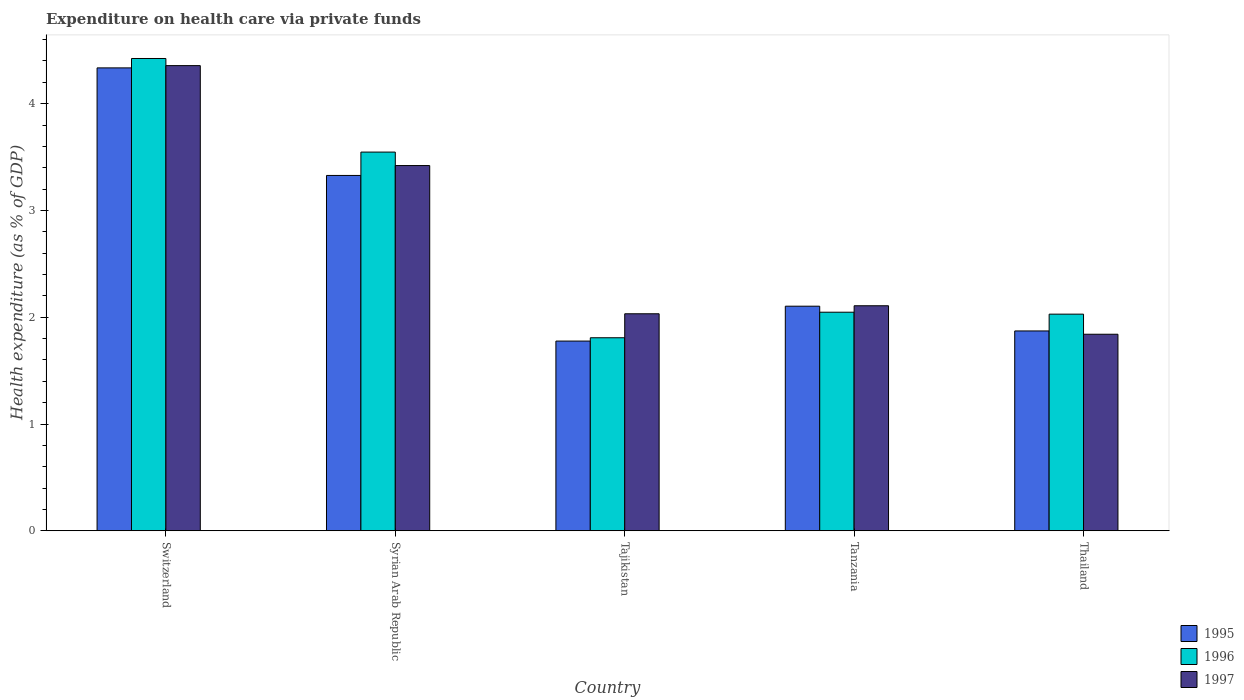How many different coloured bars are there?
Give a very brief answer. 3. How many groups of bars are there?
Your response must be concise. 5. Are the number of bars on each tick of the X-axis equal?
Your answer should be very brief. Yes. How many bars are there on the 1st tick from the left?
Make the answer very short. 3. How many bars are there on the 5th tick from the right?
Your answer should be compact. 3. What is the label of the 3rd group of bars from the left?
Provide a succinct answer. Tajikistan. What is the expenditure made on health care in 1996 in Syrian Arab Republic?
Your answer should be very brief. 3.55. Across all countries, what is the maximum expenditure made on health care in 1996?
Your answer should be compact. 4.42. Across all countries, what is the minimum expenditure made on health care in 1995?
Provide a short and direct response. 1.78. In which country was the expenditure made on health care in 1996 maximum?
Keep it short and to the point. Switzerland. In which country was the expenditure made on health care in 1997 minimum?
Your response must be concise. Thailand. What is the total expenditure made on health care in 1996 in the graph?
Your response must be concise. 13.85. What is the difference between the expenditure made on health care in 1995 in Tajikistan and that in Thailand?
Ensure brevity in your answer.  -0.09. What is the difference between the expenditure made on health care in 1997 in Syrian Arab Republic and the expenditure made on health care in 1996 in Tanzania?
Your answer should be very brief. 1.37. What is the average expenditure made on health care in 1996 per country?
Your answer should be compact. 2.77. What is the difference between the expenditure made on health care of/in 1996 and expenditure made on health care of/in 1997 in Tanzania?
Keep it short and to the point. -0.06. In how many countries, is the expenditure made on health care in 1997 greater than 0.4 %?
Your answer should be compact. 5. What is the ratio of the expenditure made on health care in 1997 in Syrian Arab Republic to that in Tanzania?
Provide a succinct answer. 1.62. Is the difference between the expenditure made on health care in 1996 in Tanzania and Thailand greater than the difference between the expenditure made on health care in 1997 in Tanzania and Thailand?
Offer a very short reply. No. What is the difference between the highest and the second highest expenditure made on health care in 1996?
Give a very brief answer. -1.5. What is the difference between the highest and the lowest expenditure made on health care in 1995?
Provide a short and direct response. 2.56. In how many countries, is the expenditure made on health care in 1997 greater than the average expenditure made on health care in 1997 taken over all countries?
Make the answer very short. 2. What does the 2nd bar from the left in Tajikistan represents?
Ensure brevity in your answer.  1996. Is it the case that in every country, the sum of the expenditure made on health care in 1995 and expenditure made on health care in 1996 is greater than the expenditure made on health care in 1997?
Offer a very short reply. Yes. How many bars are there?
Provide a short and direct response. 15. Are the values on the major ticks of Y-axis written in scientific E-notation?
Give a very brief answer. No. Does the graph contain any zero values?
Provide a short and direct response. No. Does the graph contain grids?
Offer a very short reply. No. Where does the legend appear in the graph?
Your answer should be very brief. Bottom right. How many legend labels are there?
Keep it short and to the point. 3. How are the legend labels stacked?
Make the answer very short. Vertical. What is the title of the graph?
Your response must be concise. Expenditure on health care via private funds. What is the label or title of the Y-axis?
Provide a succinct answer. Health expenditure (as % of GDP). What is the Health expenditure (as % of GDP) of 1995 in Switzerland?
Offer a very short reply. 4.33. What is the Health expenditure (as % of GDP) in 1996 in Switzerland?
Your answer should be very brief. 4.42. What is the Health expenditure (as % of GDP) of 1997 in Switzerland?
Your answer should be compact. 4.36. What is the Health expenditure (as % of GDP) of 1995 in Syrian Arab Republic?
Give a very brief answer. 3.33. What is the Health expenditure (as % of GDP) in 1996 in Syrian Arab Republic?
Keep it short and to the point. 3.55. What is the Health expenditure (as % of GDP) of 1997 in Syrian Arab Republic?
Your answer should be compact. 3.42. What is the Health expenditure (as % of GDP) in 1995 in Tajikistan?
Provide a succinct answer. 1.78. What is the Health expenditure (as % of GDP) in 1996 in Tajikistan?
Offer a terse response. 1.81. What is the Health expenditure (as % of GDP) of 1997 in Tajikistan?
Keep it short and to the point. 2.03. What is the Health expenditure (as % of GDP) in 1995 in Tanzania?
Give a very brief answer. 2.1. What is the Health expenditure (as % of GDP) of 1996 in Tanzania?
Provide a succinct answer. 2.05. What is the Health expenditure (as % of GDP) of 1997 in Tanzania?
Provide a succinct answer. 2.11. What is the Health expenditure (as % of GDP) of 1995 in Thailand?
Provide a short and direct response. 1.87. What is the Health expenditure (as % of GDP) of 1996 in Thailand?
Your response must be concise. 2.03. What is the Health expenditure (as % of GDP) in 1997 in Thailand?
Your response must be concise. 1.84. Across all countries, what is the maximum Health expenditure (as % of GDP) in 1995?
Provide a succinct answer. 4.33. Across all countries, what is the maximum Health expenditure (as % of GDP) of 1996?
Give a very brief answer. 4.42. Across all countries, what is the maximum Health expenditure (as % of GDP) of 1997?
Your response must be concise. 4.36. Across all countries, what is the minimum Health expenditure (as % of GDP) of 1995?
Offer a very short reply. 1.78. Across all countries, what is the minimum Health expenditure (as % of GDP) in 1996?
Provide a short and direct response. 1.81. Across all countries, what is the minimum Health expenditure (as % of GDP) of 1997?
Provide a short and direct response. 1.84. What is the total Health expenditure (as % of GDP) of 1995 in the graph?
Provide a succinct answer. 13.41. What is the total Health expenditure (as % of GDP) of 1996 in the graph?
Keep it short and to the point. 13.85. What is the total Health expenditure (as % of GDP) in 1997 in the graph?
Provide a succinct answer. 13.76. What is the difference between the Health expenditure (as % of GDP) of 1996 in Switzerland and that in Syrian Arab Republic?
Your answer should be compact. 0.88. What is the difference between the Health expenditure (as % of GDP) in 1997 in Switzerland and that in Syrian Arab Republic?
Ensure brevity in your answer.  0.94. What is the difference between the Health expenditure (as % of GDP) of 1995 in Switzerland and that in Tajikistan?
Your answer should be compact. 2.56. What is the difference between the Health expenditure (as % of GDP) in 1996 in Switzerland and that in Tajikistan?
Your response must be concise. 2.62. What is the difference between the Health expenditure (as % of GDP) of 1997 in Switzerland and that in Tajikistan?
Keep it short and to the point. 2.32. What is the difference between the Health expenditure (as % of GDP) of 1995 in Switzerland and that in Tanzania?
Keep it short and to the point. 2.23. What is the difference between the Health expenditure (as % of GDP) of 1996 in Switzerland and that in Tanzania?
Offer a very short reply. 2.38. What is the difference between the Health expenditure (as % of GDP) in 1997 in Switzerland and that in Tanzania?
Your answer should be very brief. 2.25. What is the difference between the Health expenditure (as % of GDP) in 1995 in Switzerland and that in Thailand?
Keep it short and to the point. 2.46. What is the difference between the Health expenditure (as % of GDP) of 1996 in Switzerland and that in Thailand?
Offer a very short reply. 2.39. What is the difference between the Health expenditure (as % of GDP) in 1997 in Switzerland and that in Thailand?
Your answer should be very brief. 2.52. What is the difference between the Health expenditure (as % of GDP) of 1995 in Syrian Arab Republic and that in Tajikistan?
Offer a very short reply. 1.55. What is the difference between the Health expenditure (as % of GDP) in 1996 in Syrian Arab Republic and that in Tajikistan?
Ensure brevity in your answer.  1.74. What is the difference between the Health expenditure (as % of GDP) in 1997 in Syrian Arab Republic and that in Tajikistan?
Make the answer very short. 1.39. What is the difference between the Health expenditure (as % of GDP) of 1995 in Syrian Arab Republic and that in Tanzania?
Provide a short and direct response. 1.22. What is the difference between the Health expenditure (as % of GDP) in 1996 in Syrian Arab Republic and that in Tanzania?
Your answer should be very brief. 1.5. What is the difference between the Health expenditure (as % of GDP) of 1997 in Syrian Arab Republic and that in Tanzania?
Ensure brevity in your answer.  1.31. What is the difference between the Health expenditure (as % of GDP) of 1995 in Syrian Arab Republic and that in Thailand?
Your answer should be very brief. 1.46. What is the difference between the Health expenditure (as % of GDP) of 1996 in Syrian Arab Republic and that in Thailand?
Offer a very short reply. 1.52. What is the difference between the Health expenditure (as % of GDP) of 1997 in Syrian Arab Republic and that in Thailand?
Provide a succinct answer. 1.58. What is the difference between the Health expenditure (as % of GDP) in 1995 in Tajikistan and that in Tanzania?
Your response must be concise. -0.33. What is the difference between the Health expenditure (as % of GDP) of 1996 in Tajikistan and that in Tanzania?
Keep it short and to the point. -0.24. What is the difference between the Health expenditure (as % of GDP) in 1997 in Tajikistan and that in Tanzania?
Offer a very short reply. -0.08. What is the difference between the Health expenditure (as % of GDP) in 1995 in Tajikistan and that in Thailand?
Your answer should be very brief. -0.09. What is the difference between the Health expenditure (as % of GDP) of 1996 in Tajikistan and that in Thailand?
Your answer should be compact. -0.22. What is the difference between the Health expenditure (as % of GDP) in 1997 in Tajikistan and that in Thailand?
Your response must be concise. 0.19. What is the difference between the Health expenditure (as % of GDP) of 1995 in Tanzania and that in Thailand?
Keep it short and to the point. 0.23. What is the difference between the Health expenditure (as % of GDP) in 1996 in Tanzania and that in Thailand?
Your response must be concise. 0.02. What is the difference between the Health expenditure (as % of GDP) of 1997 in Tanzania and that in Thailand?
Your response must be concise. 0.27. What is the difference between the Health expenditure (as % of GDP) of 1995 in Switzerland and the Health expenditure (as % of GDP) of 1996 in Syrian Arab Republic?
Your response must be concise. 0.79. What is the difference between the Health expenditure (as % of GDP) of 1995 in Switzerland and the Health expenditure (as % of GDP) of 1997 in Syrian Arab Republic?
Offer a terse response. 0.91. What is the difference between the Health expenditure (as % of GDP) of 1995 in Switzerland and the Health expenditure (as % of GDP) of 1996 in Tajikistan?
Your response must be concise. 2.53. What is the difference between the Health expenditure (as % of GDP) in 1995 in Switzerland and the Health expenditure (as % of GDP) in 1997 in Tajikistan?
Offer a terse response. 2.3. What is the difference between the Health expenditure (as % of GDP) of 1996 in Switzerland and the Health expenditure (as % of GDP) of 1997 in Tajikistan?
Ensure brevity in your answer.  2.39. What is the difference between the Health expenditure (as % of GDP) in 1995 in Switzerland and the Health expenditure (as % of GDP) in 1996 in Tanzania?
Provide a succinct answer. 2.29. What is the difference between the Health expenditure (as % of GDP) in 1995 in Switzerland and the Health expenditure (as % of GDP) in 1997 in Tanzania?
Provide a succinct answer. 2.23. What is the difference between the Health expenditure (as % of GDP) in 1996 in Switzerland and the Health expenditure (as % of GDP) in 1997 in Tanzania?
Offer a terse response. 2.32. What is the difference between the Health expenditure (as % of GDP) of 1995 in Switzerland and the Health expenditure (as % of GDP) of 1996 in Thailand?
Keep it short and to the point. 2.31. What is the difference between the Health expenditure (as % of GDP) in 1995 in Switzerland and the Health expenditure (as % of GDP) in 1997 in Thailand?
Your answer should be very brief. 2.49. What is the difference between the Health expenditure (as % of GDP) of 1996 in Switzerland and the Health expenditure (as % of GDP) of 1997 in Thailand?
Offer a terse response. 2.58. What is the difference between the Health expenditure (as % of GDP) of 1995 in Syrian Arab Republic and the Health expenditure (as % of GDP) of 1996 in Tajikistan?
Your response must be concise. 1.52. What is the difference between the Health expenditure (as % of GDP) of 1995 in Syrian Arab Republic and the Health expenditure (as % of GDP) of 1997 in Tajikistan?
Offer a very short reply. 1.3. What is the difference between the Health expenditure (as % of GDP) in 1996 in Syrian Arab Republic and the Health expenditure (as % of GDP) in 1997 in Tajikistan?
Give a very brief answer. 1.51. What is the difference between the Health expenditure (as % of GDP) in 1995 in Syrian Arab Republic and the Health expenditure (as % of GDP) in 1996 in Tanzania?
Provide a short and direct response. 1.28. What is the difference between the Health expenditure (as % of GDP) of 1995 in Syrian Arab Republic and the Health expenditure (as % of GDP) of 1997 in Tanzania?
Provide a short and direct response. 1.22. What is the difference between the Health expenditure (as % of GDP) of 1996 in Syrian Arab Republic and the Health expenditure (as % of GDP) of 1997 in Tanzania?
Your answer should be very brief. 1.44. What is the difference between the Health expenditure (as % of GDP) in 1995 in Syrian Arab Republic and the Health expenditure (as % of GDP) in 1996 in Thailand?
Provide a short and direct response. 1.3. What is the difference between the Health expenditure (as % of GDP) of 1995 in Syrian Arab Republic and the Health expenditure (as % of GDP) of 1997 in Thailand?
Offer a terse response. 1.49. What is the difference between the Health expenditure (as % of GDP) in 1996 in Syrian Arab Republic and the Health expenditure (as % of GDP) in 1997 in Thailand?
Make the answer very short. 1.71. What is the difference between the Health expenditure (as % of GDP) in 1995 in Tajikistan and the Health expenditure (as % of GDP) in 1996 in Tanzania?
Provide a succinct answer. -0.27. What is the difference between the Health expenditure (as % of GDP) of 1995 in Tajikistan and the Health expenditure (as % of GDP) of 1997 in Tanzania?
Ensure brevity in your answer.  -0.33. What is the difference between the Health expenditure (as % of GDP) in 1996 in Tajikistan and the Health expenditure (as % of GDP) in 1997 in Tanzania?
Your answer should be very brief. -0.3. What is the difference between the Health expenditure (as % of GDP) of 1995 in Tajikistan and the Health expenditure (as % of GDP) of 1996 in Thailand?
Provide a succinct answer. -0.25. What is the difference between the Health expenditure (as % of GDP) of 1995 in Tajikistan and the Health expenditure (as % of GDP) of 1997 in Thailand?
Ensure brevity in your answer.  -0.06. What is the difference between the Health expenditure (as % of GDP) of 1996 in Tajikistan and the Health expenditure (as % of GDP) of 1997 in Thailand?
Your answer should be compact. -0.03. What is the difference between the Health expenditure (as % of GDP) of 1995 in Tanzania and the Health expenditure (as % of GDP) of 1996 in Thailand?
Offer a very short reply. 0.07. What is the difference between the Health expenditure (as % of GDP) in 1995 in Tanzania and the Health expenditure (as % of GDP) in 1997 in Thailand?
Your answer should be compact. 0.26. What is the difference between the Health expenditure (as % of GDP) in 1996 in Tanzania and the Health expenditure (as % of GDP) in 1997 in Thailand?
Provide a succinct answer. 0.21. What is the average Health expenditure (as % of GDP) in 1995 per country?
Make the answer very short. 2.68. What is the average Health expenditure (as % of GDP) in 1996 per country?
Provide a short and direct response. 2.77. What is the average Health expenditure (as % of GDP) in 1997 per country?
Offer a terse response. 2.75. What is the difference between the Health expenditure (as % of GDP) in 1995 and Health expenditure (as % of GDP) in 1996 in Switzerland?
Ensure brevity in your answer.  -0.09. What is the difference between the Health expenditure (as % of GDP) of 1995 and Health expenditure (as % of GDP) of 1997 in Switzerland?
Your answer should be very brief. -0.02. What is the difference between the Health expenditure (as % of GDP) of 1996 and Health expenditure (as % of GDP) of 1997 in Switzerland?
Your response must be concise. 0.07. What is the difference between the Health expenditure (as % of GDP) in 1995 and Health expenditure (as % of GDP) in 1996 in Syrian Arab Republic?
Offer a terse response. -0.22. What is the difference between the Health expenditure (as % of GDP) in 1995 and Health expenditure (as % of GDP) in 1997 in Syrian Arab Republic?
Offer a terse response. -0.09. What is the difference between the Health expenditure (as % of GDP) in 1996 and Health expenditure (as % of GDP) in 1997 in Syrian Arab Republic?
Provide a succinct answer. 0.13. What is the difference between the Health expenditure (as % of GDP) of 1995 and Health expenditure (as % of GDP) of 1996 in Tajikistan?
Offer a terse response. -0.03. What is the difference between the Health expenditure (as % of GDP) in 1995 and Health expenditure (as % of GDP) in 1997 in Tajikistan?
Offer a very short reply. -0.26. What is the difference between the Health expenditure (as % of GDP) in 1996 and Health expenditure (as % of GDP) in 1997 in Tajikistan?
Offer a very short reply. -0.22. What is the difference between the Health expenditure (as % of GDP) of 1995 and Health expenditure (as % of GDP) of 1996 in Tanzania?
Provide a succinct answer. 0.06. What is the difference between the Health expenditure (as % of GDP) of 1995 and Health expenditure (as % of GDP) of 1997 in Tanzania?
Your answer should be very brief. -0. What is the difference between the Health expenditure (as % of GDP) of 1996 and Health expenditure (as % of GDP) of 1997 in Tanzania?
Give a very brief answer. -0.06. What is the difference between the Health expenditure (as % of GDP) in 1995 and Health expenditure (as % of GDP) in 1996 in Thailand?
Offer a terse response. -0.16. What is the difference between the Health expenditure (as % of GDP) in 1995 and Health expenditure (as % of GDP) in 1997 in Thailand?
Give a very brief answer. 0.03. What is the difference between the Health expenditure (as % of GDP) of 1996 and Health expenditure (as % of GDP) of 1997 in Thailand?
Provide a short and direct response. 0.19. What is the ratio of the Health expenditure (as % of GDP) in 1995 in Switzerland to that in Syrian Arab Republic?
Your response must be concise. 1.3. What is the ratio of the Health expenditure (as % of GDP) in 1996 in Switzerland to that in Syrian Arab Republic?
Your answer should be compact. 1.25. What is the ratio of the Health expenditure (as % of GDP) of 1997 in Switzerland to that in Syrian Arab Republic?
Your answer should be compact. 1.27. What is the ratio of the Health expenditure (as % of GDP) of 1995 in Switzerland to that in Tajikistan?
Offer a very short reply. 2.44. What is the ratio of the Health expenditure (as % of GDP) in 1996 in Switzerland to that in Tajikistan?
Offer a terse response. 2.45. What is the ratio of the Health expenditure (as % of GDP) of 1997 in Switzerland to that in Tajikistan?
Your answer should be very brief. 2.14. What is the ratio of the Health expenditure (as % of GDP) in 1995 in Switzerland to that in Tanzania?
Give a very brief answer. 2.06. What is the ratio of the Health expenditure (as % of GDP) in 1996 in Switzerland to that in Tanzania?
Offer a very short reply. 2.16. What is the ratio of the Health expenditure (as % of GDP) of 1997 in Switzerland to that in Tanzania?
Your response must be concise. 2.07. What is the ratio of the Health expenditure (as % of GDP) of 1995 in Switzerland to that in Thailand?
Provide a succinct answer. 2.32. What is the ratio of the Health expenditure (as % of GDP) in 1996 in Switzerland to that in Thailand?
Keep it short and to the point. 2.18. What is the ratio of the Health expenditure (as % of GDP) of 1997 in Switzerland to that in Thailand?
Keep it short and to the point. 2.37. What is the ratio of the Health expenditure (as % of GDP) in 1995 in Syrian Arab Republic to that in Tajikistan?
Give a very brief answer. 1.87. What is the ratio of the Health expenditure (as % of GDP) of 1996 in Syrian Arab Republic to that in Tajikistan?
Your answer should be compact. 1.96. What is the ratio of the Health expenditure (as % of GDP) of 1997 in Syrian Arab Republic to that in Tajikistan?
Make the answer very short. 1.68. What is the ratio of the Health expenditure (as % of GDP) in 1995 in Syrian Arab Republic to that in Tanzania?
Keep it short and to the point. 1.58. What is the ratio of the Health expenditure (as % of GDP) of 1996 in Syrian Arab Republic to that in Tanzania?
Ensure brevity in your answer.  1.73. What is the ratio of the Health expenditure (as % of GDP) in 1997 in Syrian Arab Republic to that in Tanzania?
Your response must be concise. 1.62. What is the ratio of the Health expenditure (as % of GDP) of 1995 in Syrian Arab Republic to that in Thailand?
Keep it short and to the point. 1.78. What is the ratio of the Health expenditure (as % of GDP) of 1996 in Syrian Arab Republic to that in Thailand?
Your answer should be compact. 1.75. What is the ratio of the Health expenditure (as % of GDP) in 1997 in Syrian Arab Republic to that in Thailand?
Make the answer very short. 1.86. What is the ratio of the Health expenditure (as % of GDP) in 1995 in Tajikistan to that in Tanzania?
Make the answer very short. 0.84. What is the ratio of the Health expenditure (as % of GDP) of 1996 in Tajikistan to that in Tanzania?
Provide a short and direct response. 0.88. What is the ratio of the Health expenditure (as % of GDP) of 1997 in Tajikistan to that in Tanzania?
Your answer should be very brief. 0.96. What is the ratio of the Health expenditure (as % of GDP) of 1995 in Tajikistan to that in Thailand?
Your answer should be very brief. 0.95. What is the ratio of the Health expenditure (as % of GDP) in 1996 in Tajikistan to that in Thailand?
Give a very brief answer. 0.89. What is the ratio of the Health expenditure (as % of GDP) in 1997 in Tajikistan to that in Thailand?
Your response must be concise. 1.1. What is the ratio of the Health expenditure (as % of GDP) in 1995 in Tanzania to that in Thailand?
Your response must be concise. 1.12. What is the ratio of the Health expenditure (as % of GDP) in 1996 in Tanzania to that in Thailand?
Provide a succinct answer. 1.01. What is the ratio of the Health expenditure (as % of GDP) in 1997 in Tanzania to that in Thailand?
Provide a succinct answer. 1.14. What is the difference between the highest and the second highest Health expenditure (as % of GDP) of 1995?
Provide a short and direct response. 1.01. What is the difference between the highest and the second highest Health expenditure (as % of GDP) of 1996?
Keep it short and to the point. 0.88. What is the difference between the highest and the second highest Health expenditure (as % of GDP) in 1997?
Your answer should be very brief. 0.94. What is the difference between the highest and the lowest Health expenditure (as % of GDP) in 1995?
Your response must be concise. 2.56. What is the difference between the highest and the lowest Health expenditure (as % of GDP) in 1996?
Your answer should be compact. 2.62. What is the difference between the highest and the lowest Health expenditure (as % of GDP) in 1997?
Ensure brevity in your answer.  2.52. 